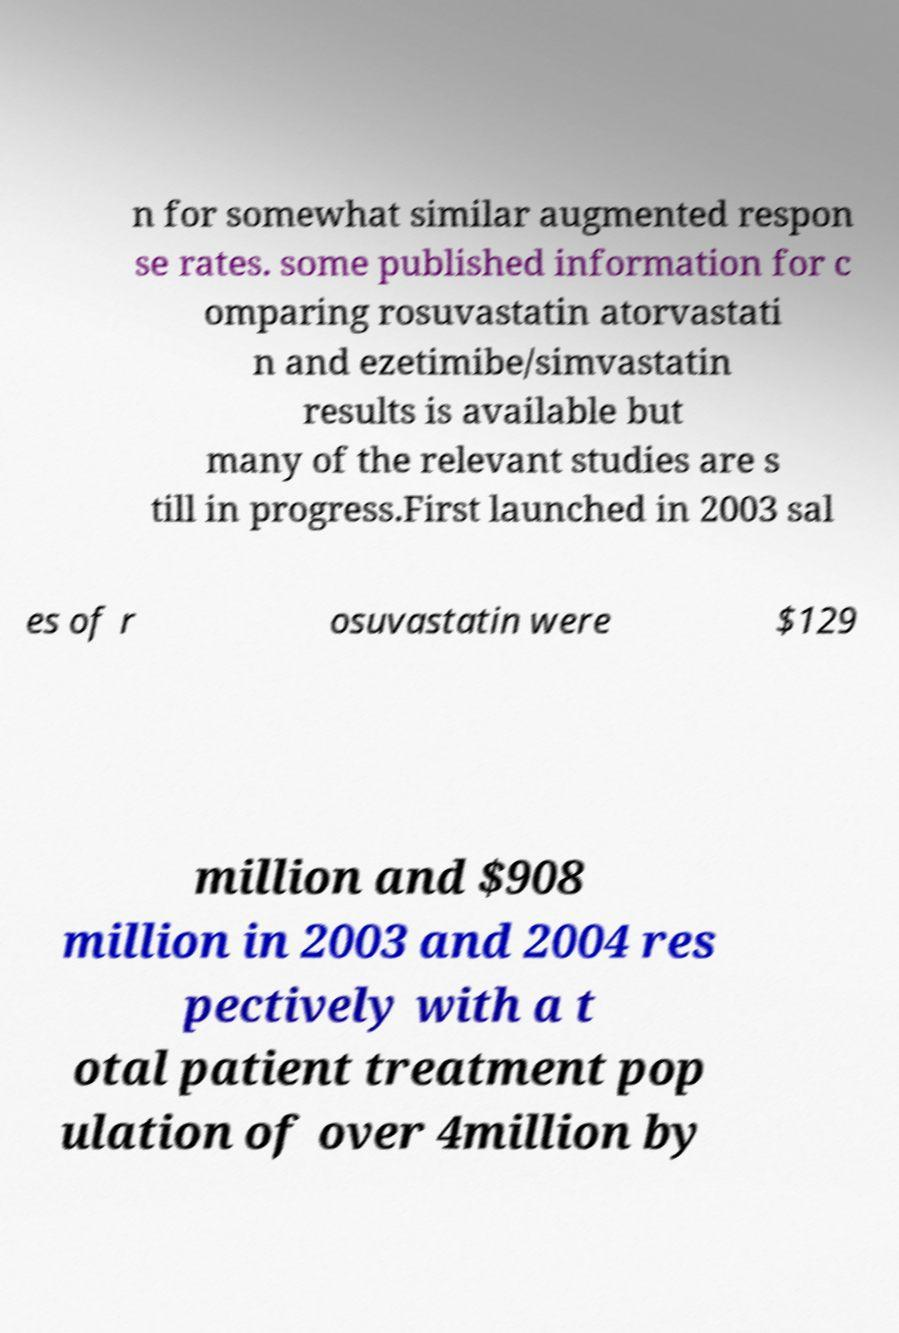There's text embedded in this image that I need extracted. Can you transcribe it verbatim? n for somewhat similar augmented respon se rates. some published information for c omparing rosuvastatin atorvastati n and ezetimibe/simvastatin results is available but many of the relevant studies are s till in progress.First launched in 2003 sal es of r osuvastatin were $129 million and $908 million in 2003 and 2004 res pectively with a t otal patient treatment pop ulation of over 4million by 